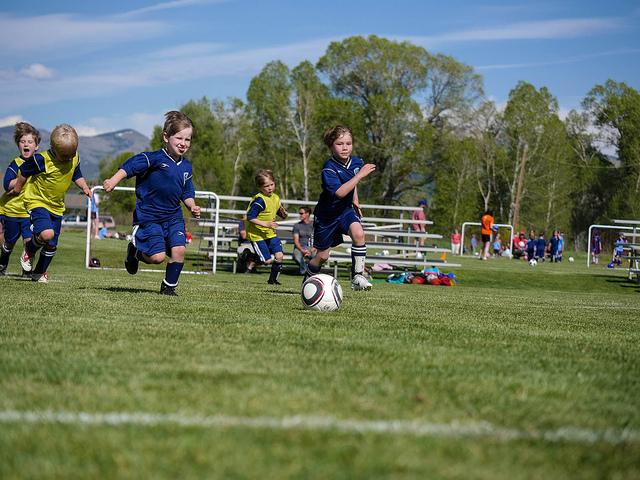Which kid will kick the ball?
Keep it brief. One on far right. What color are their uniforms?
Short answer required. Blue. Are they playing a game?
Concise answer only. Yes. 